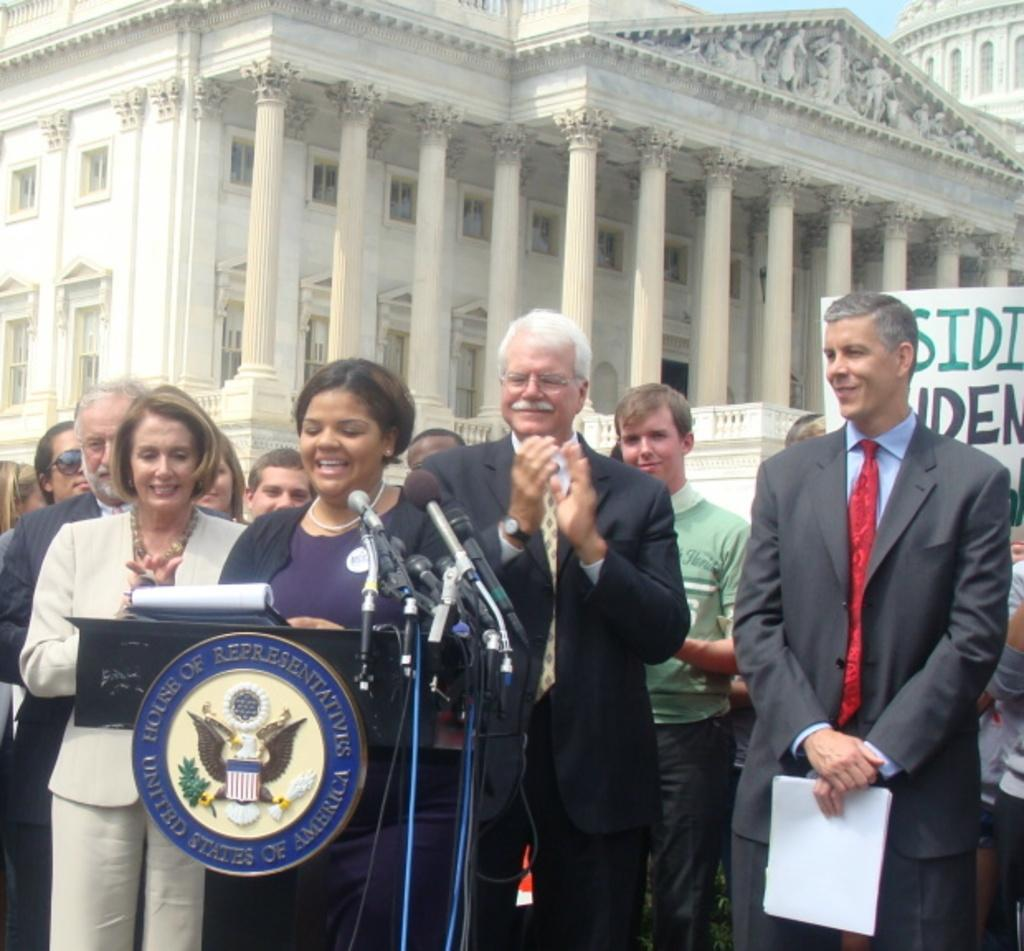What is happening in the image? There are people standing in the image, and a woman is standing and talking in front of a podium. What objects are present to help amplify the woman's voice? There are microphones present in the image. What can be seen in the background of the image? There is a building in the background of the image. What type of garden can be seen in the image? There is no garden present in the image. What prose is the woman reading from the podium? The image does not show the woman reading any prose; she is talking without any visible text. 